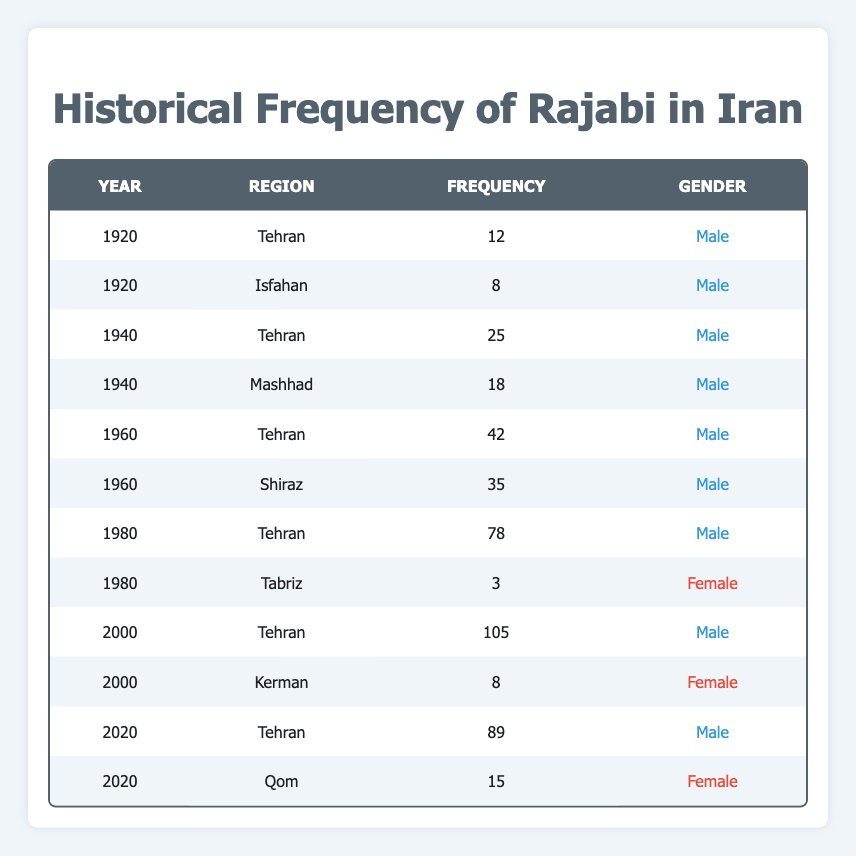What was the frequency of the name Rajabi in Tehran in 1980? In the table, I look for the entry where the region is Tehran and the year is 1980. It shows a frequency of 78.
Answer: 78 How many total occurrences of the name Rajabi were recorded for males in 1960? For the year 1960, I find all entries with male gender. There are two: Tehran (42) and Shiraz (35). Summing these gives 42 + 35 = 77.
Answer: 77 Was the name Rajabi recorded for females in the year 2000? I check the year 2000 for any female entries. There is one entry for Kerman, which has a frequency of 8, confirming that it was recorded for females that year.
Answer: Yes What was the highest recorded frequency of the name Rajabi, and in which year did it occur? I review all frequencies listed in the table, identifying the highest value. The maximum is 105 for Tehran in the year 2000.
Answer: 105 in 2000 How does the frequency of the name Rajabi in Tehran in 2020 compare to that in 1980? I find the frequencies for both years in Tehran: in 1980 it is 78, and in 2020 it is 89. By comparing them, I see that 89 - 78 = 11, meaning there was an increase of 11 from 1980 to 2020.
Answer: Increased by 11 What is the total frequency of the name Rajabi across all data points presented in the table? I sum up all frequencies listed in the table: (12 + 8 + 25 + 18 + 42 + 35 + 78 + 3 + 105 + 8 + 89 + 15) = 440.
Answer: 440 Which region had the lowest frequency of the name Rajabi, and what was that frequency? I scan all entries and identify the lowest frequency. The lowest recorded frequency is 3 in Tabriz in 1980 for females.
Answer: Tabriz with a frequency of 3 How many male entries are present in the data? I count the rows with "Male" in the gender column. There are 8 male entries in total across the years.
Answer: 8 What was the average frequency of the name Rajabi for females across the years provided? I count the female entries (two: Tabriz 3, Kerman 8), sum them (3 + 8 = 11), then divide by the number of female entries, which is 2. So, the average is 11 / 2 = 5.5.
Answer: 5.5 